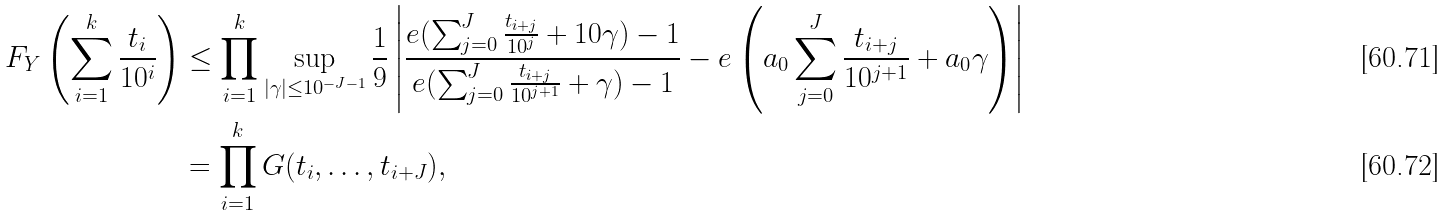Convert formula to latex. <formula><loc_0><loc_0><loc_500><loc_500>F _ { Y } \left ( \sum _ { i = 1 } ^ { k } \frac { t _ { i } } { 1 0 ^ { i } } \right ) & \leq \prod _ { i = 1 } ^ { k } \sup _ { | \gamma | \leq 1 0 ^ { - J - 1 } } \frac { 1 } { 9 } \left | \frac { e ( \sum _ { j = 0 } ^ { J } \frac { t _ { i + j } } { 1 0 ^ { j } } + 1 0 \gamma ) - 1 } { e ( \sum _ { j = 0 } ^ { J } \frac { t _ { i + j } } { 1 0 ^ { j + 1 } } + \gamma ) - 1 } - e \left ( a _ { 0 } \sum _ { j = 0 } ^ { J } \frac { t _ { i + j } } { 1 0 ^ { j + 1 } } + a _ { 0 } \gamma \right ) \right | \\ & = \prod _ { i = 1 } ^ { k } G ( t _ { i } , \dots , t _ { i + J } ) ,</formula> 